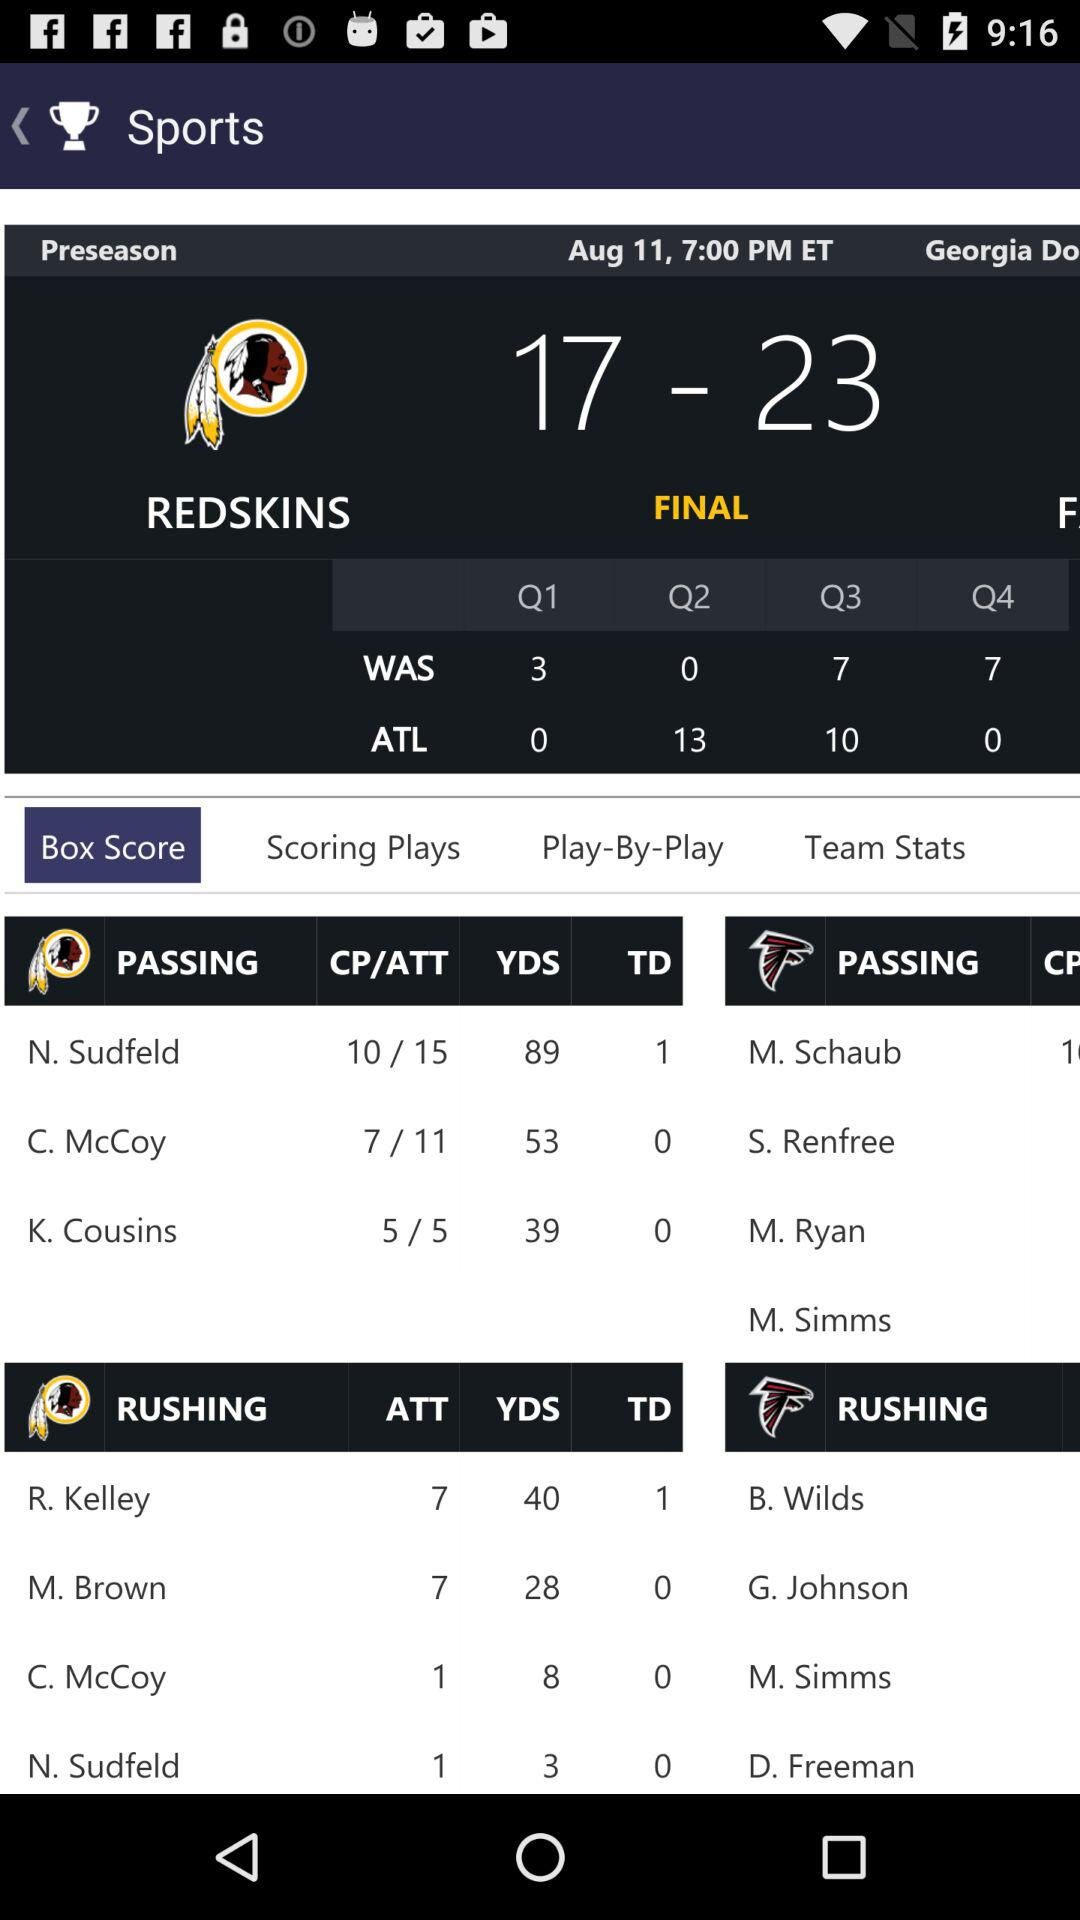How many preseason games are left?
When the provided information is insufficient, respond with <no answer>. <no answer> 